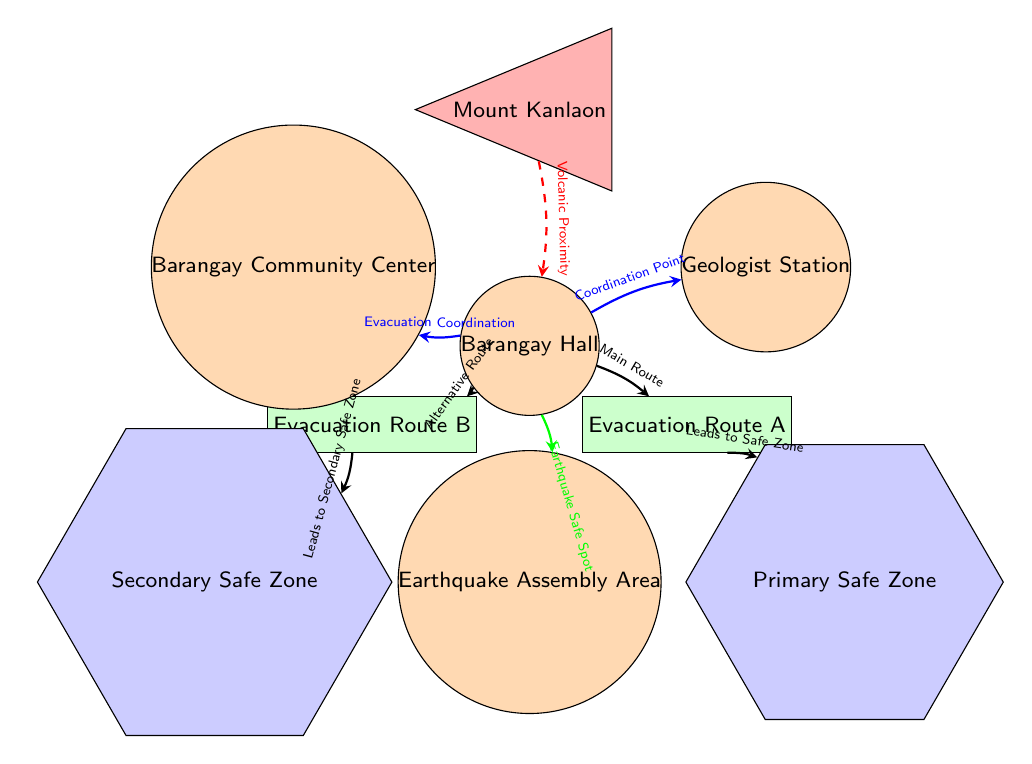What is the primary safe zone labeled in the diagram? The primary safe zone is represented by the node labeled as "Primary Safe Zone," which is located below Evacuation Route A.
Answer: Primary Safe Zone How many evacuation routes are identified in the diagram? The diagram identifies two evacuation routes, labeled as "Evacuation Route A" and "Evacuation Route B."
Answer: 2 What symbol represents Mount Kanlaon in the diagram? Mount Kanlaon is represented by an isosceles triangle shape filled with red, indicating its volcanic nature.
Answer: Red triangle What is the evacuation route leading to the secondary safe zone? The evacuation route leading to the secondary safe zone is labeled as "Evacuation Route B," which directs towards the node of the secondary safe zone.
Answer: Evacuation Route B Where is the Earthquake Assembly Area located? The Earthquake Assembly Area is labeled and located directly below the Barangay Hall at the bottom of the diagram.
Answer: Earthquake Assembly Area What is the purpose of the Geologist Station in the evacuation diagram? The Geologist Station serves as a coordination point for evacuation efforts related to the volcanic activity and safety instructions.
Answer: Coordination Point How many safe zones are depicted on the diagram? There are two safe zones, namely "Primary Safe Zone" and "Secondary Safe Zone," clearly indicated in the diagram.
Answer: 2 Which evacuation route is indicated as the main route? The main route is indicated from the Barangay Hall to Evacuation Route A, clearly labeled as "Main Route."
Answer: Evacuation Route A Which area is marked as a volcanic proximity in the diagram? The area marked for volcanic proximity is the Barangay Hall, indicated by a red dashed arrow originating from Mount Kanlaon.
Answer: Barangay Hall 